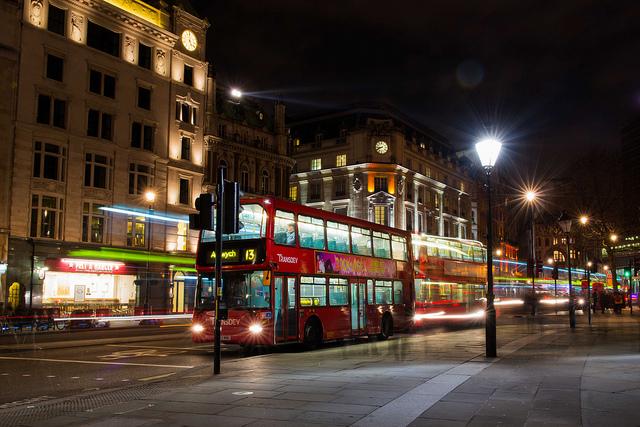Is this a time lapse photo?
Give a very brief answer. No. What is your favorite travel destination?
Concise answer only. London. How many floors does the bus have?
Write a very short answer. 2. What does the red sign sell?
Quick response, please. Food. What color is the bus?
Quick response, please. Red. How many buildings are visible?
Keep it brief. 3. 